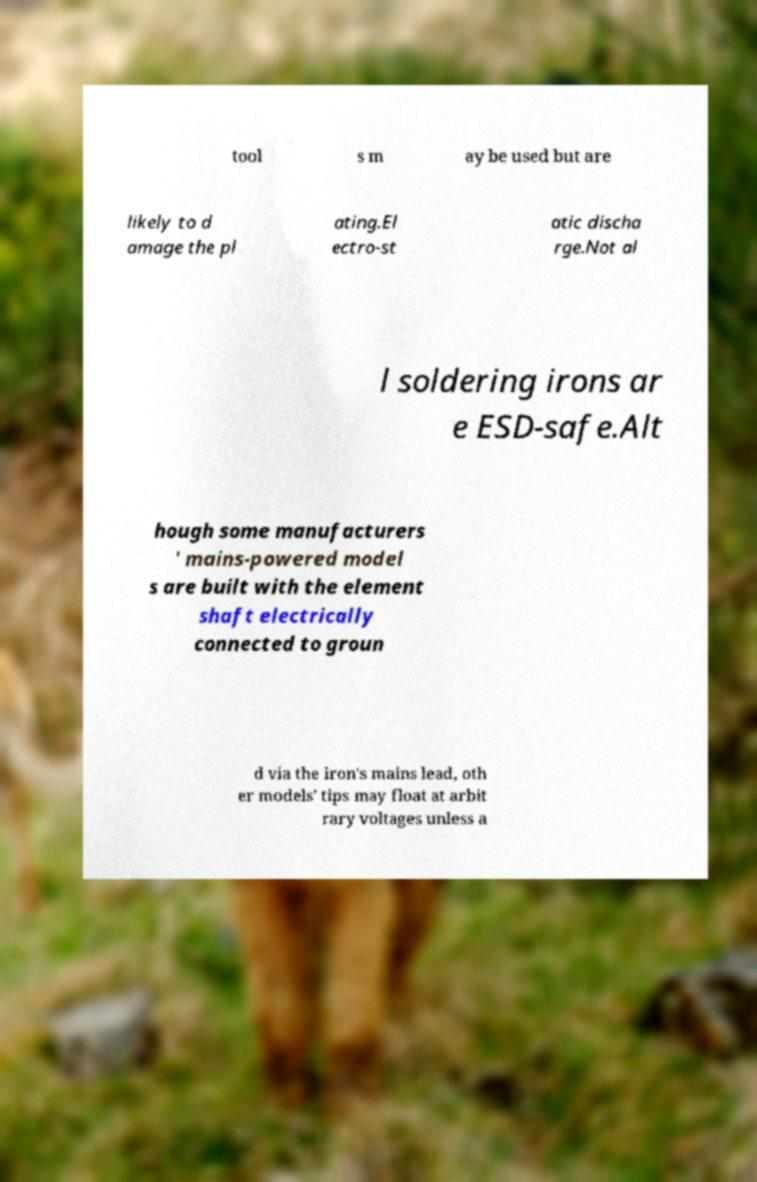Can you read and provide the text displayed in the image?This photo seems to have some interesting text. Can you extract and type it out for me? tool s m ay be used but are likely to d amage the pl ating.El ectro-st atic discha rge.Not al l soldering irons ar e ESD-safe.Alt hough some manufacturers ' mains-powered model s are built with the element shaft electrically connected to groun d via the iron's mains lead, oth er models' tips may float at arbit rary voltages unless a 